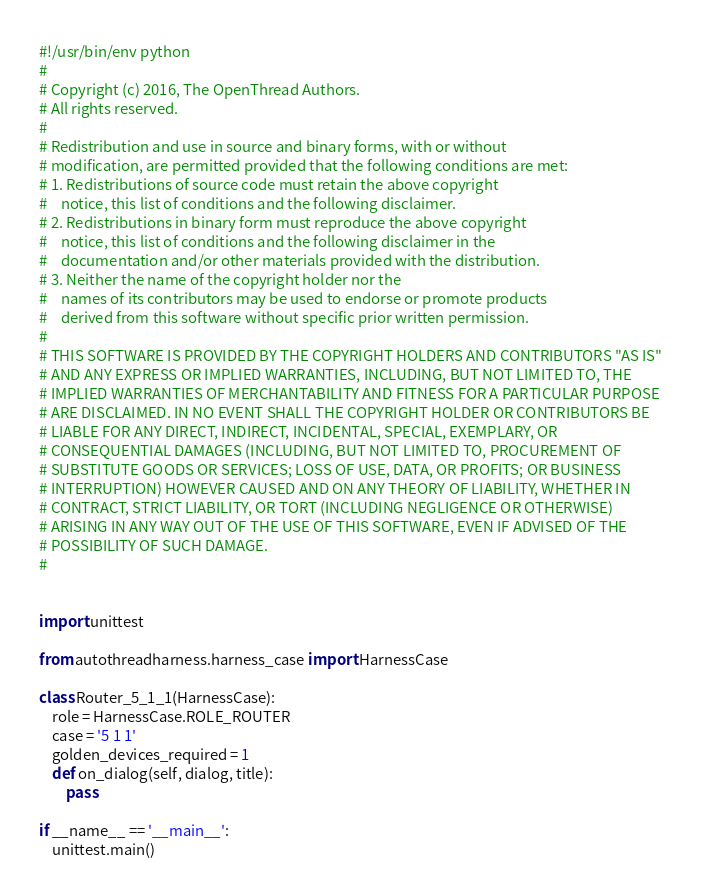Convert code to text. <code><loc_0><loc_0><loc_500><loc_500><_Python_>#!/usr/bin/env python
#
# Copyright (c) 2016, The OpenThread Authors.
# All rights reserved.
#
# Redistribution and use in source and binary forms, with or without
# modification, are permitted provided that the following conditions are met:
# 1. Redistributions of source code must retain the above copyright
#    notice, this list of conditions and the following disclaimer.
# 2. Redistributions in binary form must reproduce the above copyright
#    notice, this list of conditions and the following disclaimer in the
#    documentation and/or other materials provided with the distribution.
# 3. Neither the name of the copyright holder nor the
#    names of its contributors may be used to endorse or promote products
#    derived from this software without specific prior written permission.
#
# THIS SOFTWARE IS PROVIDED BY THE COPYRIGHT HOLDERS AND CONTRIBUTORS "AS IS"
# AND ANY EXPRESS OR IMPLIED WARRANTIES, INCLUDING, BUT NOT LIMITED TO, THE
# IMPLIED WARRANTIES OF MERCHANTABILITY AND FITNESS FOR A PARTICULAR PURPOSE
# ARE DISCLAIMED. IN NO EVENT SHALL THE COPYRIGHT HOLDER OR CONTRIBUTORS BE
# LIABLE FOR ANY DIRECT, INDIRECT, INCIDENTAL, SPECIAL, EXEMPLARY, OR
# CONSEQUENTIAL DAMAGES (INCLUDING, BUT NOT LIMITED TO, PROCUREMENT OF
# SUBSTITUTE GOODS OR SERVICES; LOSS OF USE, DATA, OR PROFITS; OR BUSINESS
# INTERRUPTION) HOWEVER CAUSED AND ON ANY THEORY OF LIABILITY, WHETHER IN
# CONTRACT, STRICT LIABILITY, OR TORT (INCLUDING NEGLIGENCE OR OTHERWISE)
# ARISING IN ANY WAY OUT OF THE USE OF THIS SOFTWARE, EVEN IF ADVISED OF THE
# POSSIBILITY OF SUCH DAMAGE.
#


import unittest

from autothreadharness.harness_case import HarnessCase

class Router_5_1_1(HarnessCase):
    role = HarnessCase.ROLE_ROUTER
    case = '5 1 1'
    golden_devices_required = 1
    def on_dialog(self, dialog, title):
        pass

if __name__ == '__main__':
    unittest.main()
</code> 